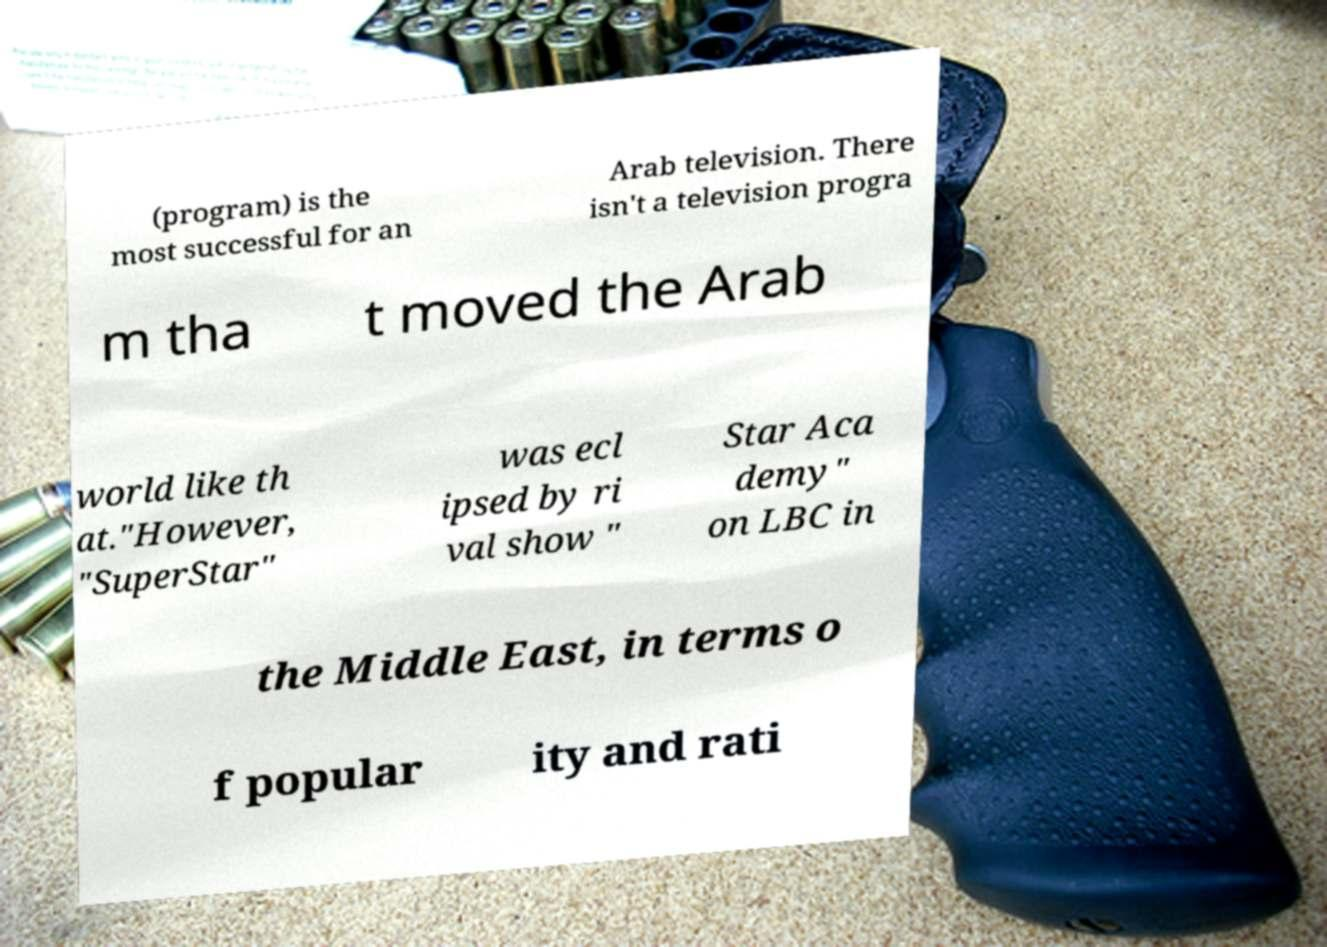For documentation purposes, I need the text within this image transcribed. Could you provide that? (program) is the most successful for an Arab television. There isn't a television progra m tha t moved the Arab world like th at."However, "SuperStar" was ecl ipsed by ri val show " Star Aca demy" on LBC in the Middle East, in terms o f popular ity and rati 